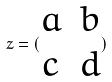Convert formula to latex. <formula><loc_0><loc_0><loc_500><loc_500>z = ( \begin{matrix} a & b \\ c & d \end{matrix} )</formula> 